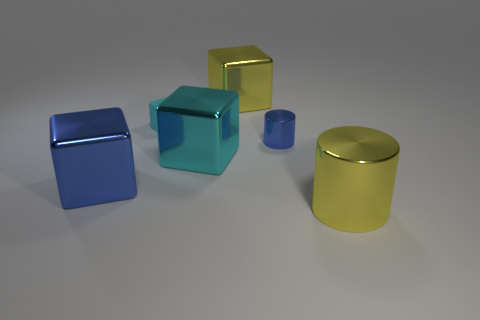What is the color of the small shiny object?
Offer a very short reply. Blue. There is a cube that is on the right side of the cyan matte thing and in front of the tiny shiny cylinder; how big is it?
Give a very brief answer. Large. How many objects are large metal cubes that are behind the tiny cyan object or cyan things?
Offer a terse response. 3. There is a cyan object that is the same material as the blue cube; what shape is it?
Ensure brevity in your answer.  Cube. What is the shape of the small metal thing?
Your answer should be compact. Cylinder. What color is the thing that is both to the left of the cyan metallic cube and in front of the big cyan metallic thing?
Offer a terse response. Blue. There is a object that is the same size as the blue metallic cylinder; what shape is it?
Offer a terse response. Cube. Is there another matte object that has the same shape as the big cyan thing?
Your answer should be very brief. Yes. Do the big cyan cube and the large thing to the left of the small cube have the same material?
Make the answer very short. Yes. There is a big metal block that is behind the cyan rubber cube in front of the large yellow object behind the cyan rubber object; what color is it?
Your answer should be compact. Yellow. 